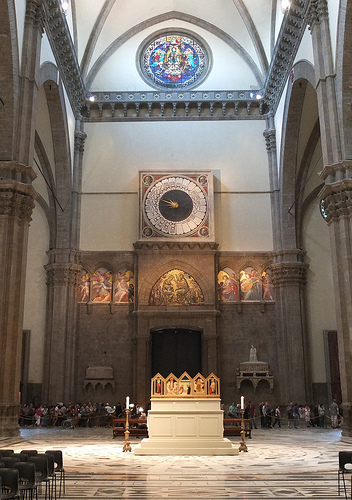Can you describe the type of architecture in this image? The architecture in this image appears to be Gothic, noted for its pointed arches, high ceilings, and large stained-glass windows, which can be seen in the circular window at the top. 